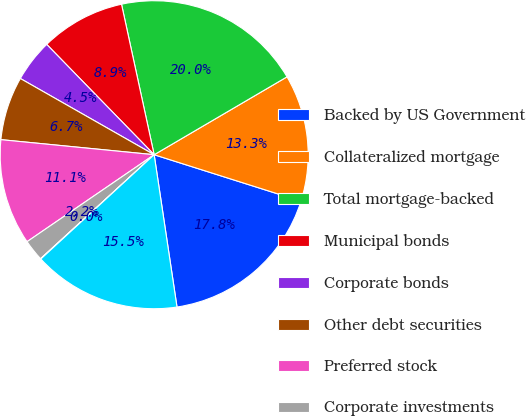Convert chart to OTSL. <chart><loc_0><loc_0><loc_500><loc_500><pie_chart><fcel>Backed by US Government<fcel>Collateralized mortgage<fcel>Total mortgage-backed<fcel>Municipal bonds<fcel>Corporate bonds<fcel>Other debt securities<fcel>Preferred stock<fcel>Corporate investments<fcel>Retained interest from<fcel>Total investment securities<nl><fcel>17.75%<fcel>13.32%<fcel>19.96%<fcel>8.89%<fcel>4.47%<fcel>6.68%<fcel>11.11%<fcel>2.25%<fcel>0.04%<fcel>15.53%<nl></chart> 